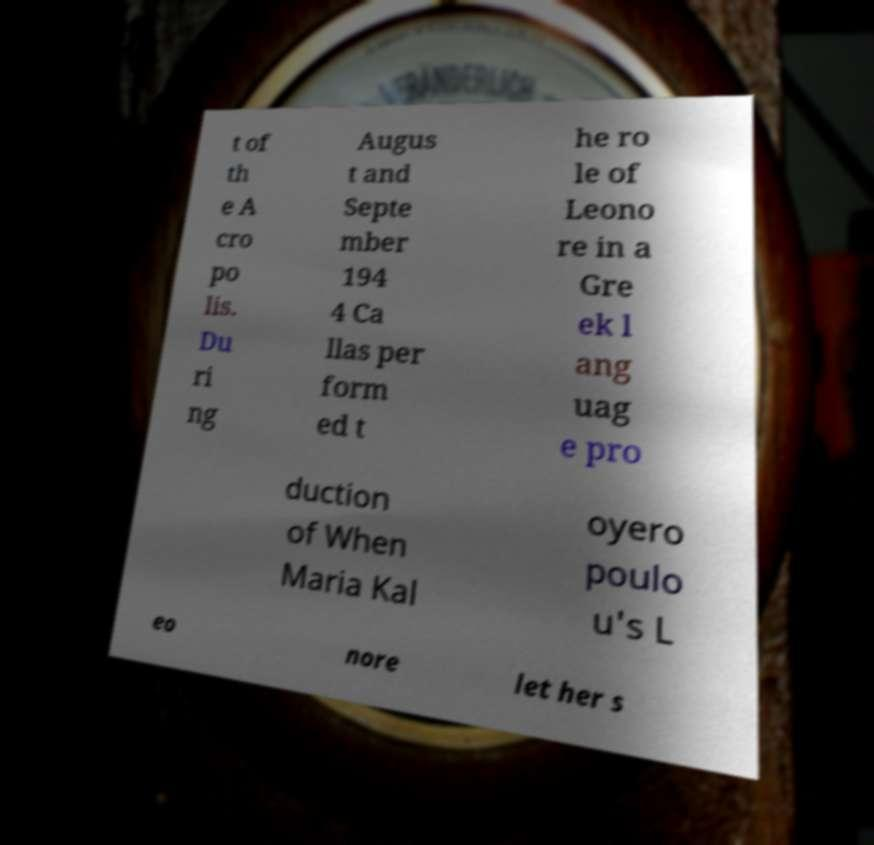Could you assist in decoding the text presented in this image and type it out clearly? t of th e A cro po lis. Du ri ng Augus t and Septe mber 194 4 Ca llas per form ed t he ro le of Leono re in a Gre ek l ang uag e pro duction of When Maria Kal oyero poulo u's L eo nore let her s 